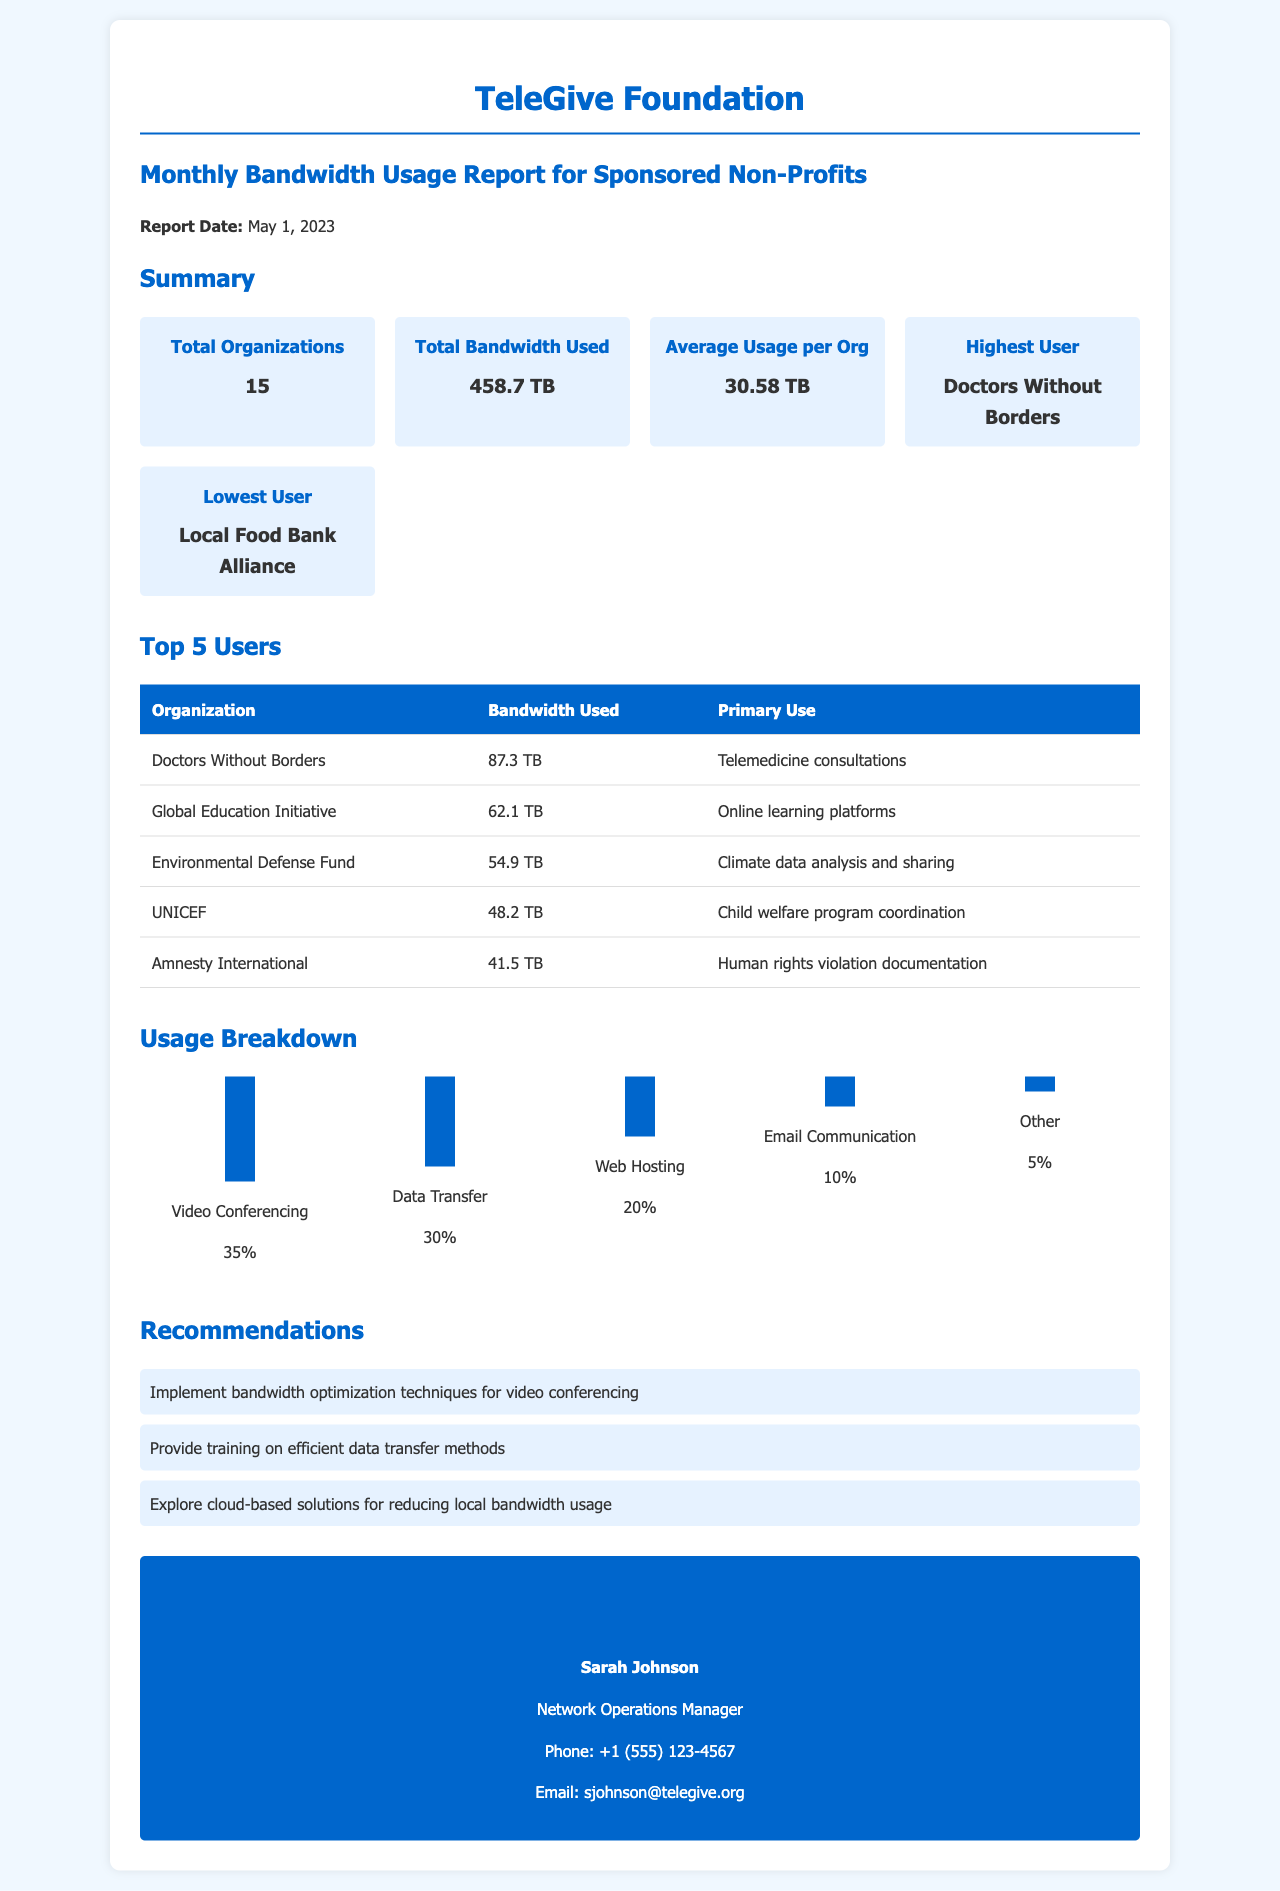What is the total number of organizations? The total number of organizations is stated in the summary section of the document.
Answer: 15 What is the total bandwidth used? The total bandwidth used is presented in the summary section of the document.
Answer: 458.7 TB Who is the highest user? The highest user is identified in the summary section of the document.
Answer: Doctors Without Borders What was the primary use of bandwidth by Global Education Initiative? The primary use of bandwidth for Global Education Initiative is mentioned in the top users section.
Answer: Online learning platforms What percentage of bandwidth was used for video conferencing? The percentage of bandwidth used for video conferencing is displayed in the usage breakdown section.
Answer: 35% Which organization had the lowest bandwidth usage? The organization with the lowest bandwidth usage is listed in the summary section of the document.
Answer: Local Food Bank Alliance What is one recommendation given in the document? One recommendation is included in the recommendations section of the document.
Answer: Implement bandwidth optimization techniques for video conferencing Who is the contact person for this report? The contact person is specified in the contact information section of the document.
Answer: Sarah Johnson 